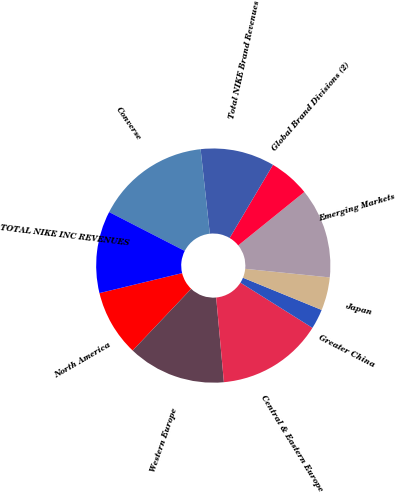Convert chart to OTSL. <chart><loc_0><loc_0><loc_500><loc_500><pie_chart><fcel>North America<fcel>Western Europe<fcel>Central & Eastern Europe<fcel>Greater China<fcel>Japan<fcel>Emerging Markets<fcel>Global Brand Divisions (2)<fcel>Total NIKE Brand Revenues<fcel>Converse<fcel>TOTAL NIKE INC REVENUES<nl><fcel>9.14%<fcel>13.53%<fcel>14.63%<fcel>2.74%<fcel>4.57%<fcel>12.43%<fcel>5.67%<fcel>10.24%<fcel>15.72%<fcel>11.33%<nl></chart> 